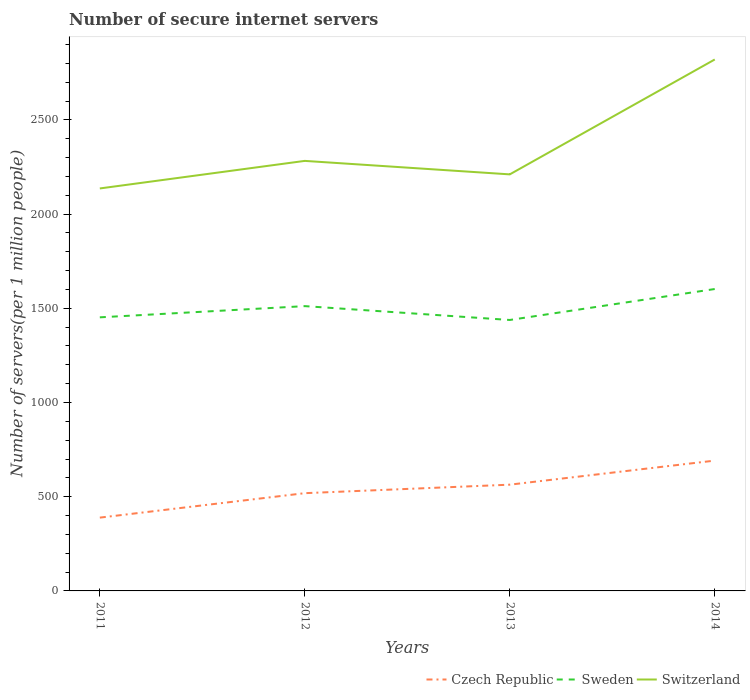Across all years, what is the maximum number of secure internet servers in Switzerland?
Offer a very short reply. 2136.01. In which year was the number of secure internet servers in Switzerland maximum?
Your response must be concise. 2011. What is the total number of secure internet servers in Switzerland in the graph?
Make the answer very short. -146.26. What is the difference between the highest and the second highest number of secure internet servers in Switzerland?
Offer a terse response. 684.42. What is the difference between the highest and the lowest number of secure internet servers in Sweden?
Offer a very short reply. 2. How many lines are there?
Provide a short and direct response. 3. What is the difference between two consecutive major ticks on the Y-axis?
Your answer should be very brief. 500. Are the values on the major ticks of Y-axis written in scientific E-notation?
Your response must be concise. No. Where does the legend appear in the graph?
Keep it short and to the point. Bottom right. How many legend labels are there?
Give a very brief answer. 3. What is the title of the graph?
Offer a terse response. Number of secure internet servers. Does "Upper middle income" appear as one of the legend labels in the graph?
Your answer should be compact. No. What is the label or title of the X-axis?
Provide a succinct answer. Years. What is the label or title of the Y-axis?
Offer a very short reply. Number of servers(per 1 million people). What is the Number of servers(per 1 million people) of Czech Republic in 2011?
Your answer should be compact. 389. What is the Number of servers(per 1 million people) in Sweden in 2011?
Offer a terse response. 1451.97. What is the Number of servers(per 1 million people) of Switzerland in 2011?
Ensure brevity in your answer.  2136.01. What is the Number of servers(per 1 million people) in Czech Republic in 2012?
Provide a succinct answer. 518.8. What is the Number of servers(per 1 million people) in Sweden in 2012?
Offer a very short reply. 1511.44. What is the Number of servers(per 1 million people) in Switzerland in 2012?
Provide a short and direct response. 2282.27. What is the Number of servers(per 1 million people) of Czech Republic in 2013?
Offer a terse response. 563.9. What is the Number of servers(per 1 million people) in Sweden in 2013?
Your answer should be compact. 1437.96. What is the Number of servers(per 1 million people) in Switzerland in 2013?
Offer a very short reply. 2210.69. What is the Number of servers(per 1 million people) of Czech Republic in 2014?
Provide a succinct answer. 691.59. What is the Number of servers(per 1 million people) of Sweden in 2014?
Your answer should be very brief. 1602.24. What is the Number of servers(per 1 million people) of Switzerland in 2014?
Offer a very short reply. 2820.43. Across all years, what is the maximum Number of servers(per 1 million people) in Czech Republic?
Ensure brevity in your answer.  691.59. Across all years, what is the maximum Number of servers(per 1 million people) in Sweden?
Offer a very short reply. 1602.24. Across all years, what is the maximum Number of servers(per 1 million people) in Switzerland?
Offer a very short reply. 2820.43. Across all years, what is the minimum Number of servers(per 1 million people) in Czech Republic?
Offer a terse response. 389. Across all years, what is the minimum Number of servers(per 1 million people) of Sweden?
Give a very brief answer. 1437.96. Across all years, what is the minimum Number of servers(per 1 million people) in Switzerland?
Your answer should be very brief. 2136.01. What is the total Number of servers(per 1 million people) of Czech Republic in the graph?
Your response must be concise. 2163.29. What is the total Number of servers(per 1 million people) in Sweden in the graph?
Offer a terse response. 6003.62. What is the total Number of servers(per 1 million people) of Switzerland in the graph?
Provide a short and direct response. 9449.4. What is the difference between the Number of servers(per 1 million people) of Czech Republic in 2011 and that in 2012?
Provide a short and direct response. -129.8. What is the difference between the Number of servers(per 1 million people) in Sweden in 2011 and that in 2012?
Ensure brevity in your answer.  -59.47. What is the difference between the Number of servers(per 1 million people) of Switzerland in 2011 and that in 2012?
Your answer should be compact. -146.26. What is the difference between the Number of servers(per 1 million people) of Czech Republic in 2011 and that in 2013?
Your response must be concise. -174.9. What is the difference between the Number of servers(per 1 million people) in Sweden in 2011 and that in 2013?
Your answer should be very brief. 14.01. What is the difference between the Number of servers(per 1 million people) of Switzerland in 2011 and that in 2013?
Your response must be concise. -74.67. What is the difference between the Number of servers(per 1 million people) of Czech Republic in 2011 and that in 2014?
Your answer should be compact. -302.59. What is the difference between the Number of servers(per 1 million people) in Sweden in 2011 and that in 2014?
Provide a succinct answer. -150.27. What is the difference between the Number of servers(per 1 million people) of Switzerland in 2011 and that in 2014?
Offer a very short reply. -684.42. What is the difference between the Number of servers(per 1 million people) in Czech Republic in 2012 and that in 2013?
Give a very brief answer. -45.1. What is the difference between the Number of servers(per 1 million people) of Sweden in 2012 and that in 2013?
Your answer should be very brief. 73.48. What is the difference between the Number of servers(per 1 million people) of Switzerland in 2012 and that in 2013?
Ensure brevity in your answer.  71.58. What is the difference between the Number of servers(per 1 million people) in Czech Republic in 2012 and that in 2014?
Make the answer very short. -172.79. What is the difference between the Number of servers(per 1 million people) in Sweden in 2012 and that in 2014?
Your answer should be compact. -90.8. What is the difference between the Number of servers(per 1 million people) in Switzerland in 2012 and that in 2014?
Make the answer very short. -538.16. What is the difference between the Number of servers(per 1 million people) of Czech Republic in 2013 and that in 2014?
Provide a short and direct response. -127.69. What is the difference between the Number of servers(per 1 million people) of Sweden in 2013 and that in 2014?
Provide a short and direct response. -164.28. What is the difference between the Number of servers(per 1 million people) in Switzerland in 2013 and that in 2014?
Your answer should be very brief. -609.75. What is the difference between the Number of servers(per 1 million people) of Czech Republic in 2011 and the Number of servers(per 1 million people) of Sweden in 2012?
Give a very brief answer. -1122.44. What is the difference between the Number of servers(per 1 million people) in Czech Republic in 2011 and the Number of servers(per 1 million people) in Switzerland in 2012?
Your response must be concise. -1893.27. What is the difference between the Number of servers(per 1 million people) of Sweden in 2011 and the Number of servers(per 1 million people) of Switzerland in 2012?
Provide a short and direct response. -830.3. What is the difference between the Number of servers(per 1 million people) in Czech Republic in 2011 and the Number of servers(per 1 million people) in Sweden in 2013?
Your response must be concise. -1048.96. What is the difference between the Number of servers(per 1 million people) in Czech Republic in 2011 and the Number of servers(per 1 million people) in Switzerland in 2013?
Your response must be concise. -1821.68. What is the difference between the Number of servers(per 1 million people) of Sweden in 2011 and the Number of servers(per 1 million people) of Switzerland in 2013?
Your response must be concise. -758.71. What is the difference between the Number of servers(per 1 million people) of Czech Republic in 2011 and the Number of servers(per 1 million people) of Sweden in 2014?
Your answer should be very brief. -1213.24. What is the difference between the Number of servers(per 1 million people) in Czech Republic in 2011 and the Number of servers(per 1 million people) in Switzerland in 2014?
Keep it short and to the point. -2431.43. What is the difference between the Number of servers(per 1 million people) in Sweden in 2011 and the Number of servers(per 1 million people) in Switzerland in 2014?
Your response must be concise. -1368.46. What is the difference between the Number of servers(per 1 million people) in Czech Republic in 2012 and the Number of servers(per 1 million people) in Sweden in 2013?
Offer a terse response. -919.16. What is the difference between the Number of servers(per 1 million people) in Czech Republic in 2012 and the Number of servers(per 1 million people) in Switzerland in 2013?
Offer a terse response. -1691.89. What is the difference between the Number of servers(per 1 million people) in Sweden in 2012 and the Number of servers(per 1 million people) in Switzerland in 2013?
Your response must be concise. -699.24. What is the difference between the Number of servers(per 1 million people) in Czech Republic in 2012 and the Number of servers(per 1 million people) in Sweden in 2014?
Your answer should be compact. -1083.44. What is the difference between the Number of servers(per 1 million people) in Czech Republic in 2012 and the Number of servers(per 1 million people) in Switzerland in 2014?
Your answer should be very brief. -2301.63. What is the difference between the Number of servers(per 1 million people) in Sweden in 2012 and the Number of servers(per 1 million people) in Switzerland in 2014?
Give a very brief answer. -1308.99. What is the difference between the Number of servers(per 1 million people) in Czech Republic in 2013 and the Number of servers(per 1 million people) in Sweden in 2014?
Offer a very short reply. -1038.34. What is the difference between the Number of servers(per 1 million people) of Czech Republic in 2013 and the Number of servers(per 1 million people) of Switzerland in 2014?
Give a very brief answer. -2256.53. What is the difference between the Number of servers(per 1 million people) of Sweden in 2013 and the Number of servers(per 1 million people) of Switzerland in 2014?
Ensure brevity in your answer.  -1382.47. What is the average Number of servers(per 1 million people) of Czech Republic per year?
Your answer should be very brief. 540.82. What is the average Number of servers(per 1 million people) of Sweden per year?
Offer a terse response. 1500.91. What is the average Number of servers(per 1 million people) of Switzerland per year?
Make the answer very short. 2362.35. In the year 2011, what is the difference between the Number of servers(per 1 million people) of Czech Republic and Number of servers(per 1 million people) of Sweden?
Provide a short and direct response. -1062.97. In the year 2011, what is the difference between the Number of servers(per 1 million people) in Czech Republic and Number of servers(per 1 million people) in Switzerland?
Your response must be concise. -1747.01. In the year 2011, what is the difference between the Number of servers(per 1 million people) of Sweden and Number of servers(per 1 million people) of Switzerland?
Give a very brief answer. -684.04. In the year 2012, what is the difference between the Number of servers(per 1 million people) in Czech Republic and Number of servers(per 1 million people) in Sweden?
Keep it short and to the point. -992.64. In the year 2012, what is the difference between the Number of servers(per 1 million people) in Czech Republic and Number of servers(per 1 million people) in Switzerland?
Your response must be concise. -1763.47. In the year 2012, what is the difference between the Number of servers(per 1 million people) in Sweden and Number of servers(per 1 million people) in Switzerland?
Your response must be concise. -770.83. In the year 2013, what is the difference between the Number of servers(per 1 million people) in Czech Republic and Number of servers(per 1 million people) in Sweden?
Provide a short and direct response. -874.06. In the year 2013, what is the difference between the Number of servers(per 1 million people) in Czech Republic and Number of servers(per 1 million people) in Switzerland?
Keep it short and to the point. -1646.79. In the year 2013, what is the difference between the Number of servers(per 1 million people) of Sweden and Number of servers(per 1 million people) of Switzerland?
Give a very brief answer. -772.72. In the year 2014, what is the difference between the Number of servers(per 1 million people) of Czech Republic and Number of servers(per 1 million people) of Sweden?
Make the answer very short. -910.65. In the year 2014, what is the difference between the Number of servers(per 1 million people) of Czech Republic and Number of servers(per 1 million people) of Switzerland?
Offer a very short reply. -2128.84. In the year 2014, what is the difference between the Number of servers(per 1 million people) of Sweden and Number of servers(per 1 million people) of Switzerland?
Keep it short and to the point. -1218.19. What is the ratio of the Number of servers(per 1 million people) in Czech Republic in 2011 to that in 2012?
Your answer should be compact. 0.75. What is the ratio of the Number of servers(per 1 million people) in Sweden in 2011 to that in 2012?
Your response must be concise. 0.96. What is the ratio of the Number of servers(per 1 million people) in Switzerland in 2011 to that in 2012?
Keep it short and to the point. 0.94. What is the ratio of the Number of servers(per 1 million people) in Czech Republic in 2011 to that in 2013?
Your response must be concise. 0.69. What is the ratio of the Number of servers(per 1 million people) of Sweden in 2011 to that in 2013?
Your response must be concise. 1.01. What is the ratio of the Number of servers(per 1 million people) of Switzerland in 2011 to that in 2013?
Give a very brief answer. 0.97. What is the ratio of the Number of servers(per 1 million people) in Czech Republic in 2011 to that in 2014?
Offer a terse response. 0.56. What is the ratio of the Number of servers(per 1 million people) of Sweden in 2011 to that in 2014?
Give a very brief answer. 0.91. What is the ratio of the Number of servers(per 1 million people) of Switzerland in 2011 to that in 2014?
Provide a short and direct response. 0.76. What is the ratio of the Number of servers(per 1 million people) of Czech Republic in 2012 to that in 2013?
Provide a short and direct response. 0.92. What is the ratio of the Number of servers(per 1 million people) in Sweden in 2012 to that in 2013?
Provide a short and direct response. 1.05. What is the ratio of the Number of servers(per 1 million people) of Switzerland in 2012 to that in 2013?
Offer a very short reply. 1.03. What is the ratio of the Number of servers(per 1 million people) of Czech Republic in 2012 to that in 2014?
Offer a terse response. 0.75. What is the ratio of the Number of servers(per 1 million people) in Sweden in 2012 to that in 2014?
Keep it short and to the point. 0.94. What is the ratio of the Number of servers(per 1 million people) of Switzerland in 2012 to that in 2014?
Your answer should be compact. 0.81. What is the ratio of the Number of servers(per 1 million people) of Czech Republic in 2013 to that in 2014?
Your answer should be compact. 0.82. What is the ratio of the Number of servers(per 1 million people) in Sweden in 2013 to that in 2014?
Your answer should be very brief. 0.9. What is the ratio of the Number of servers(per 1 million people) of Switzerland in 2013 to that in 2014?
Ensure brevity in your answer.  0.78. What is the difference between the highest and the second highest Number of servers(per 1 million people) in Czech Republic?
Provide a succinct answer. 127.69. What is the difference between the highest and the second highest Number of servers(per 1 million people) of Sweden?
Offer a very short reply. 90.8. What is the difference between the highest and the second highest Number of servers(per 1 million people) of Switzerland?
Offer a terse response. 538.16. What is the difference between the highest and the lowest Number of servers(per 1 million people) of Czech Republic?
Your answer should be compact. 302.59. What is the difference between the highest and the lowest Number of servers(per 1 million people) of Sweden?
Provide a succinct answer. 164.28. What is the difference between the highest and the lowest Number of servers(per 1 million people) of Switzerland?
Your answer should be compact. 684.42. 